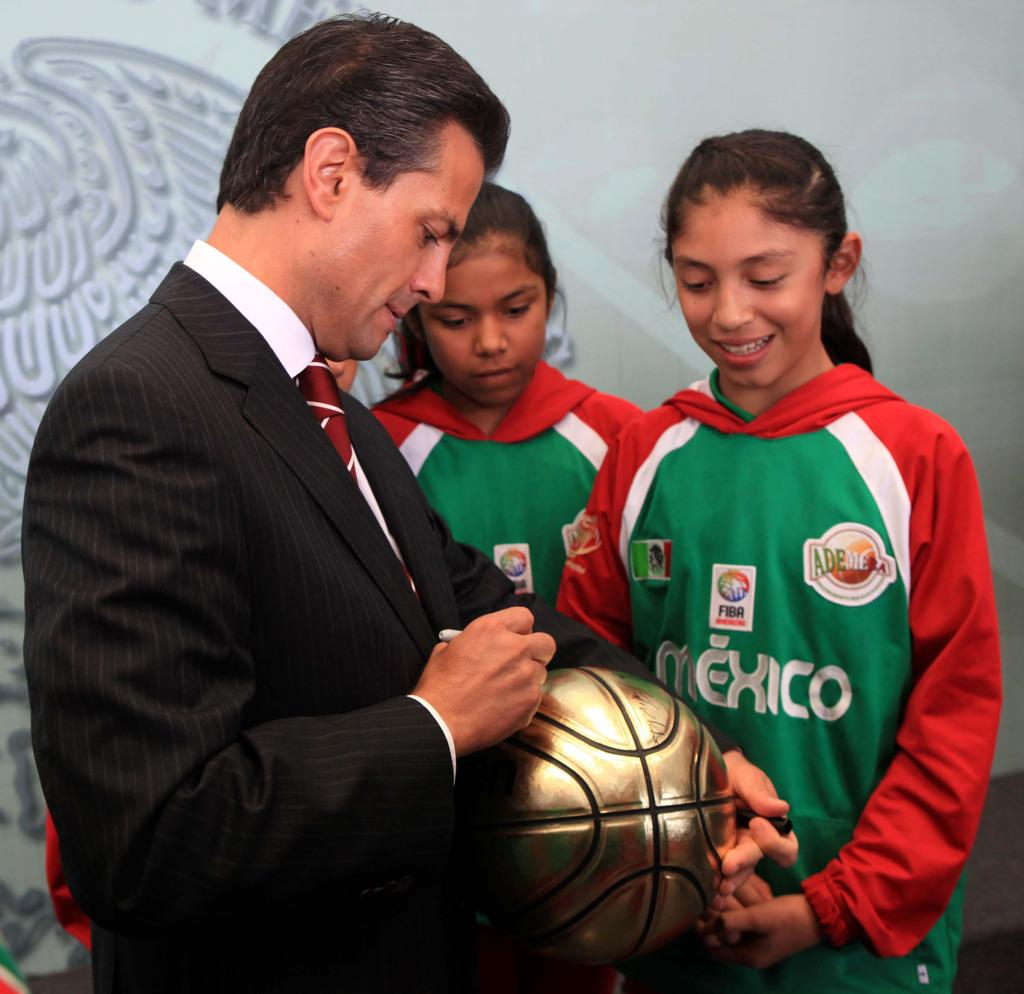Provide a one-sentence caption for the provided image. A man signing a gold soccer ball next to a girl wearing a red, white and green hoodie that says Mexico. 